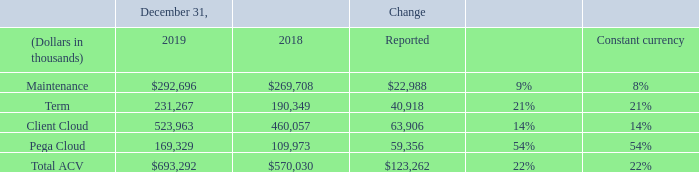Annual Contract Value (“ACV”) (1) (2)
The change in ACV measures the growth and predictability of future cash flows from committed Pega Cloud and Client Cloud arrangements as of the end of the particular reporting period.
Total ACV, as of a given date, is the sum of the following two components:
• Client Cloud: the sum of (1) the annual value of each term license contract in effect on such date, which is equal to its total license value divided by the total number of years and (2) maintenance revenue reported for the quarter ended on such date, multiplied by four. We do not provide hosting services for Client Cloud arrangements.
• Pega Cloud: the sum of the annual value of each cloud contract in effect on such date, which is equal to its total value divided by the total number of years.
(1) Data Table
(2) As foreign currency exchange rates are an important factor in understanding period to period comparisons, we believe the presentation of ACV growth rates on a constant currency basis enhances the understanding of our results and evaluation of our performance in comparison to prior periods.
What are the respective values for maintenance in 2018 and 2019?
Answer scale should be: thousand. $269,708, $292,696. What are the respective values for Term in 2018 and 2019?
Answer scale should be: thousand. 190,349, 231,267. What are the respective values for total ACV in 2018 and 2019?
Answer scale should be: thousand. $570,030, $693,292. What is the percentage change in the maintenance values between 2018 and 2019?
Answer scale should be: percent. (292,696 - 269,708)/269,708 
Answer: 8.52. What is the value of Client Cloud as a percentage of the total ACV in 2019?
Answer scale should be: percent. 523,963/693,292 
Answer: 75.58. What is the value of Pega Cloud as a percentage of the total ACV in 2019?
Answer scale should be: percent. 169,329/693,292 
Answer: 24.42. 